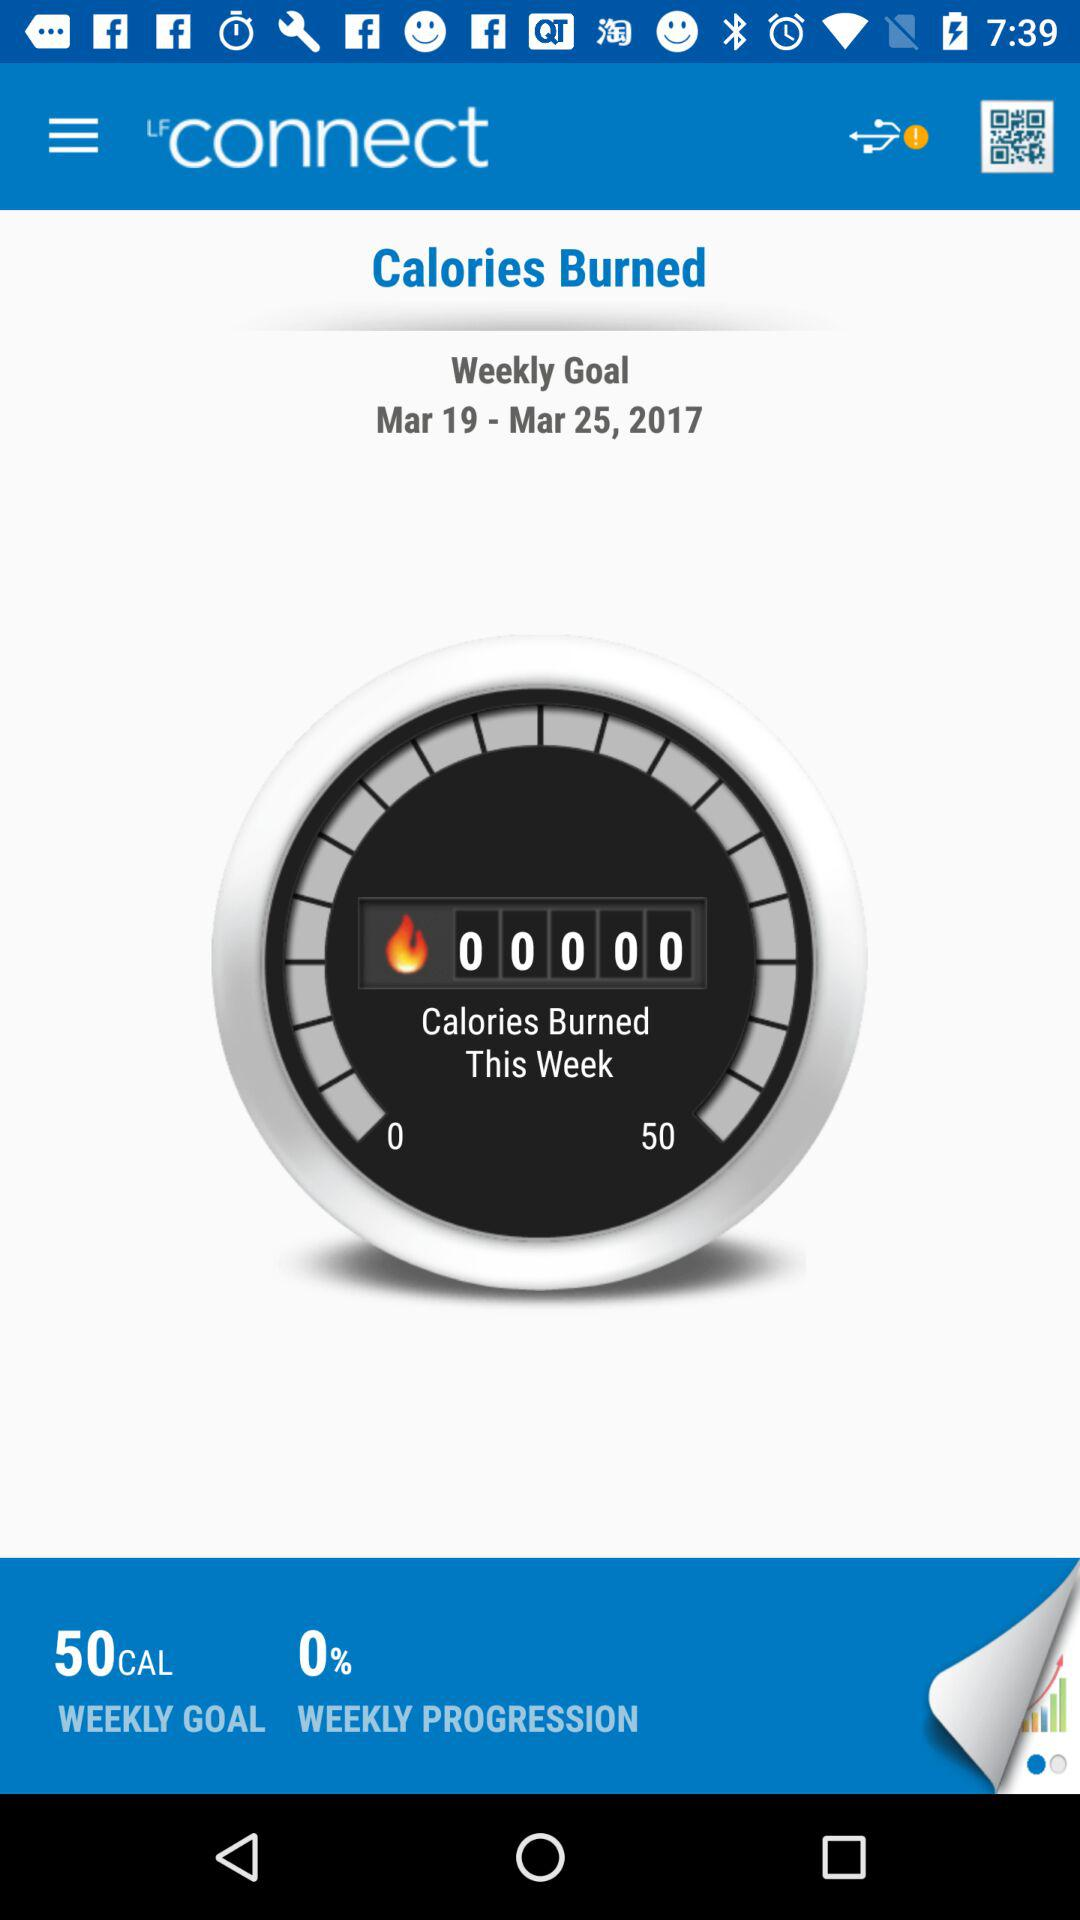What is the weekly goal? The weekly goal is to burn 50 calories. 